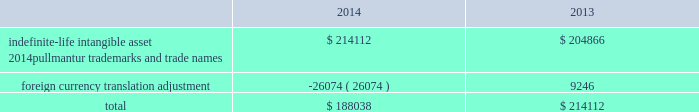Royal caribbean cruises ltd .
79 notes to the consolidated financial statements in 2012 , we determined the implied fair value of good- will for the pullmantur reporting unit was $ 145.5 mil- lion and recognized an impairment charge of $ 319.2 million based on a probability-weighted discounted cash flow model further discussed below .
This impair- ment charge was recognized in earnings during the fourth quarter of 2012 and is reported within impair- ment of pullmantur related assets within our consoli- dated statements of comprehensive income ( loss ) .
During the fourth quarter of 2014 , we performed a qualitative assessment of whether it was more-likely- than-not that our royal caribbean international reporting unit 2019s fair value was less than its carrying amount before applying the two-step goodwill impair- ment test .
The qualitative analysis included assessing the impact of certain factors such as general economic conditions , limitations on accessing capital , changes in forecasted operating results , changes in fuel prices and fluctuations in foreign exchange rates .
Based on our qualitative assessment , we concluded that it was more-likely-than-not that the estimated fair value of the royal caribbean international reporting unit exceeded its carrying value and thus , we did not pro- ceed to the two-step goodwill impairment test .
No indicators of impairment exist primarily because the reporting unit 2019s fair value has consistently exceeded its carrying value by a significant margin , its financial performance has been solid in the face of mixed economic environments and forecasts of operating results generated by the reporting unit appear suffi- cient to support its carrying value .
We also performed our annual impairment review of goodwill for pullmantur 2019s reporting unit during the fourth quarter of 2014 .
We did not perform a quali- tative assessment but instead proceeded directly to the two-step goodwill impairment test .
We estimated the fair value of the pullmantur reporting unit using a probability-weighted discounted cash flow model .
The principal assumptions used in the discounted cash flow model are projected operating results , weighted- average cost of capital , and terminal value .
Signifi- cantly impacting these assumptions are the transfer of vessels from our other cruise brands to pullmantur .
The discounted cash flow model used our 2015 pro- jected operating results as a base .
To that base , we added future years 2019 cash flows assuming multiple rev- enue and expense scenarios that reflect the impact of different global economic environments beyond 2015 on pullmantur 2019s reporting unit .
We assigned a probability to each revenue and expense scenario .
We discounted the projected cash flows using rates specific to pullmantur 2019s reporting unit based on its weighted-average cost of capital .
Based on the probability-weighted discounted cash flows , we deter- mined the fair value of the pullmantur reporting unit exceeded its carrying value by approximately 52% ( 52 % ) resulting in no impairment to pullmantur 2019s goodwill .
Pullmantur is a brand targeted primarily at the spanish , portuguese and latin american markets , with an increasing focus on latin america .
The persistent economic instability in these markets has created sig- nificant uncertainties in forecasting operating results and future cash flows used in our impairment analyses .
We continue to monitor economic events in these markets for their potential impact on pullmantur 2019s business and valuation .
Further , the estimation of fair value utilizing discounted expected future cash flows includes numerous uncertainties which require our significant judgment when making assumptions of expected revenues , operating costs , marketing , sell- ing and administrative expenses , interest rates , ship additions and retirements as well as assumptions regarding the cruise vacation industry 2019s competitive environment and general economic and business conditions , among other factors .
If there are changes to the projected future cash flows used in the impairment analyses , especially in net yields or if certain transfers of vessels from our other cruise brands to the pullmantur fleet do not take place , it is possible that an impairment charge of pullmantur 2019s reporting unit 2019s goodwill may be required .
Of these factors , the planned transfers of vessels to the pullmantur fleet is most significant to the projected future cash flows .
If the transfers do not occur , we will likely fail step one of the impairment test .
Note 4 .
Intangible assets intangible assets are reported in other assets in our consolidated balance sheets and consist of the follow- ing ( in thousands ) : .
During the fourth quarter of 2014 , 2013 and 2012 , we performed the annual impairment review of pullmantur 2019s trademarks and trade names using a discounted cash flow model and the relief-from-royalty method to compare the fair value of these indefinite-lived intan- gible assets to its carrying value .
The royalty rate used is based on comparable royalty agreements in the tourism and hospitality industry .
We used a dis- count rate comparable to the rate used in valuing the pullmantur reporting unit in our goodwill impairment test .
Based on the results of our testing , we did not .
What was the percentage increase in the intangible assets are reported in other assets from 2013 to 2014? 
Computations: ((214112 / 204866) / 204866)
Answer: 1e-05. 